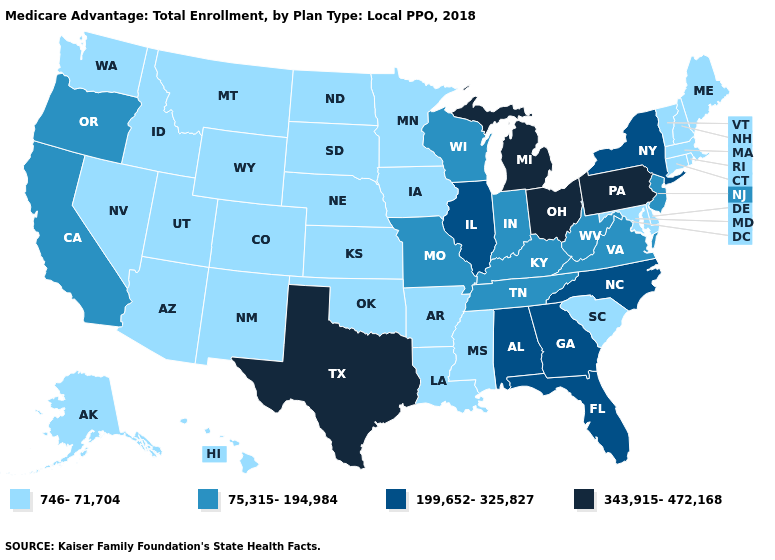Which states have the lowest value in the West?
Keep it brief. Alaska, Arizona, Colorado, Hawaii, Idaho, Montana, Nevada, New Mexico, Utah, Washington, Wyoming. Does Michigan have the highest value in the USA?
Keep it brief. Yes. Does Idaho have a lower value than Michigan?
Concise answer only. Yes. Does the first symbol in the legend represent the smallest category?
Concise answer only. Yes. What is the value of South Carolina?
Give a very brief answer. 746-71,704. Among the states that border Connecticut , does Massachusetts have the lowest value?
Quick response, please. Yes. Does Texas have the highest value in the USA?
Write a very short answer. Yes. What is the lowest value in the USA?
Quick response, please. 746-71,704. What is the value of New York?
Write a very short answer. 199,652-325,827. What is the highest value in the MidWest ?
Short answer required. 343,915-472,168. What is the value of Alaska?
Short answer required. 746-71,704. Among the states that border South Carolina , which have the highest value?
Concise answer only. Georgia, North Carolina. Which states have the highest value in the USA?
Concise answer only. Michigan, Ohio, Pennsylvania, Texas. 